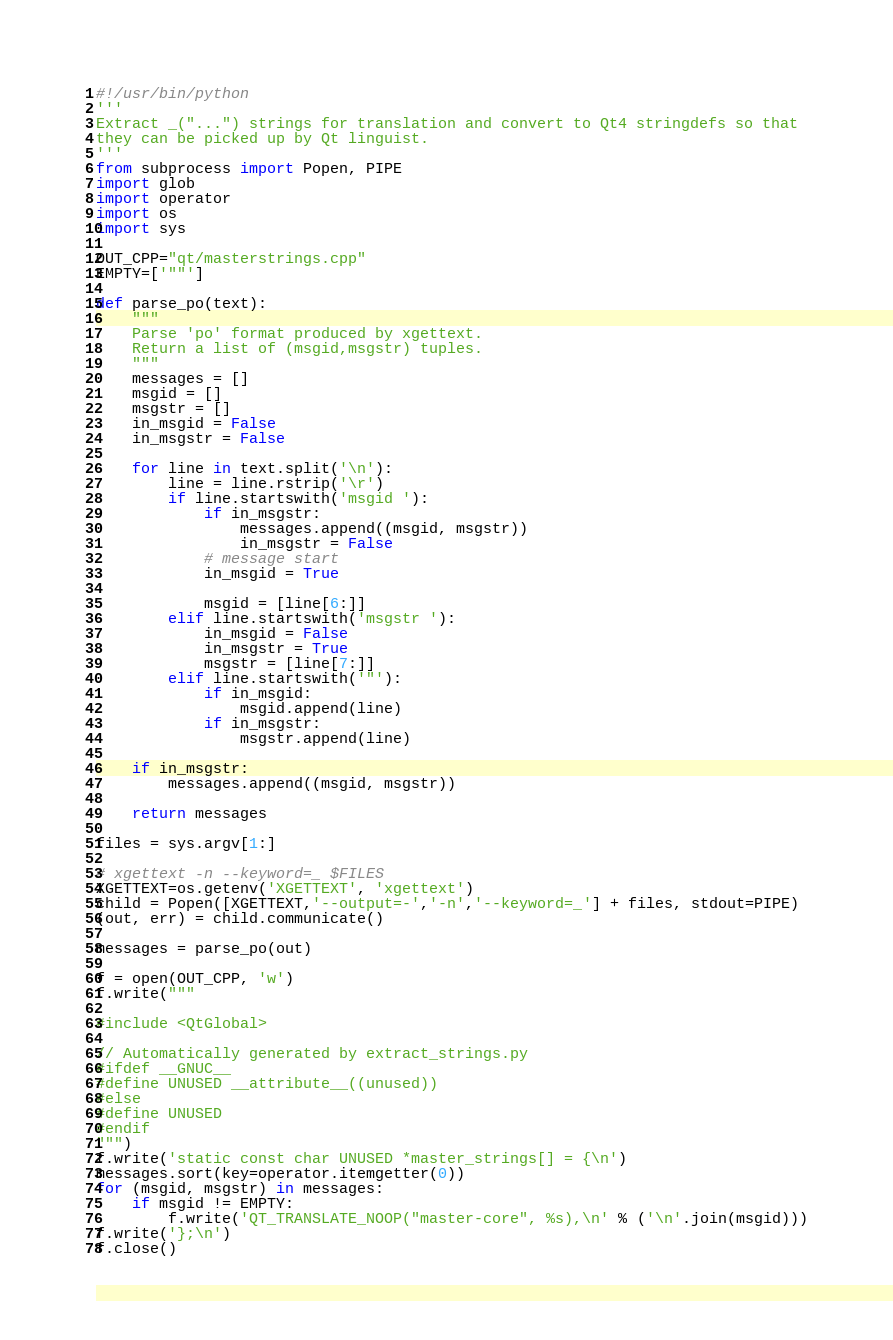Convert code to text. <code><loc_0><loc_0><loc_500><loc_500><_Python_>#!/usr/bin/python
'''
Extract _("...") strings for translation and convert to Qt4 stringdefs so that
they can be picked up by Qt linguist.
'''
from subprocess import Popen, PIPE
import glob
import operator
import os
import sys

OUT_CPP="qt/masterstrings.cpp"
EMPTY=['""']

def parse_po(text):
    """
    Parse 'po' format produced by xgettext.
    Return a list of (msgid,msgstr) tuples.
    """
    messages = []
    msgid = []
    msgstr = []
    in_msgid = False
    in_msgstr = False

    for line in text.split('\n'):
        line = line.rstrip('\r')
        if line.startswith('msgid '):
            if in_msgstr:
                messages.append((msgid, msgstr))
                in_msgstr = False
            # message start
            in_msgid = True

            msgid = [line[6:]]
        elif line.startswith('msgstr '):
            in_msgid = False
            in_msgstr = True
            msgstr = [line[7:]]
        elif line.startswith('"'):
            if in_msgid:
                msgid.append(line)
            if in_msgstr:
                msgstr.append(line)

    if in_msgstr:
        messages.append((msgid, msgstr))

    return messages

files = sys.argv[1:]

# xgettext -n --keyword=_ $FILES
XGETTEXT=os.getenv('XGETTEXT', 'xgettext')
child = Popen([XGETTEXT,'--output=-','-n','--keyword=_'] + files, stdout=PIPE)
(out, err) = child.communicate()

messages = parse_po(out)

f = open(OUT_CPP, 'w')
f.write("""

#include <QtGlobal>

// Automatically generated by extract_strings.py
#ifdef __GNUC__
#define UNUSED __attribute__((unused))
#else
#define UNUSED
#endif
""")
f.write('static const char UNUSED *master_strings[] = {\n')
messages.sort(key=operator.itemgetter(0))
for (msgid, msgstr) in messages:
    if msgid != EMPTY:
        f.write('QT_TRANSLATE_NOOP("master-core", %s),\n' % ('\n'.join(msgid)))
f.write('};\n')
f.close()
</code> 